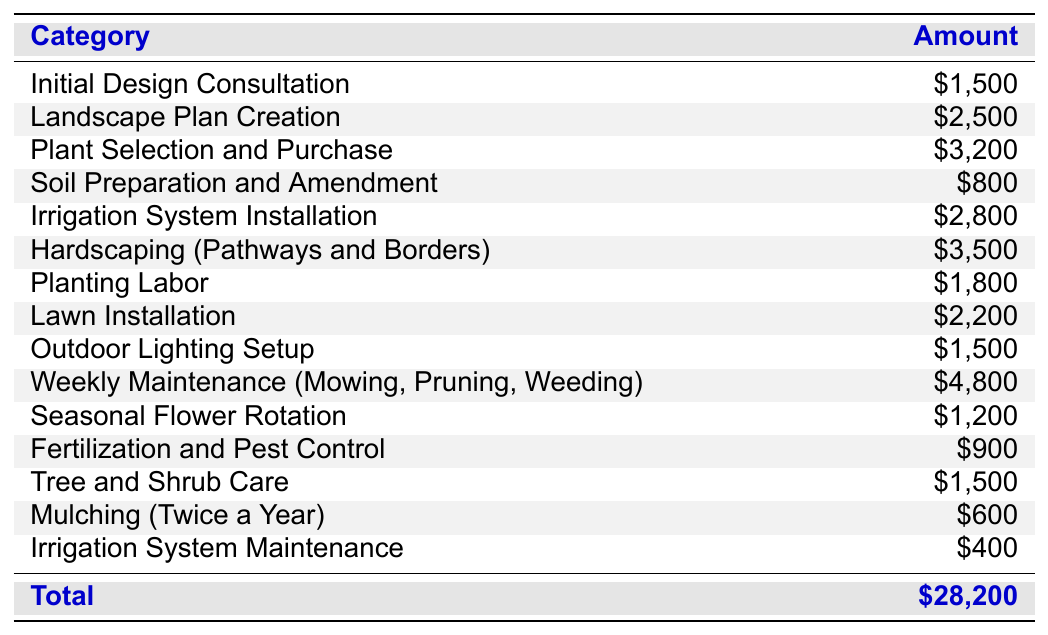What is the total amount allocated for the garden budget? The total amount is explicitly listed in the last row of the table as $28,200.
Answer: $28,200 How much is budgeted for Weekly Maintenance? The amount allocated for Weekly Maintenance is found under that category in the table, which is $4,800.
Answer: $4,800 Which category has the highest budget allocation? The highest budget allocation can be identified by comparing the amounts in each row. Hardscaping (Pathways and Borders) has the highest amount at $3,500.
Answer: Hardscaping (Pathways and Borders) What is the combined total budget for Soil Preparation and Amendment and Fertilization and Pest Control? To find the combined total, sum the amounts for Soil Preparation ($800) and Fertilization ($900): 800 + 900 = 1,700.
Answer: $1,700 Is the amount allocated for Irrigation System Maintenance greater than the total budget for Mulching and Fertilization? First, calculate the total for Mulching ($600) and Fertilization ($900), which is 600 + 900 = 1,500. Irrigation System Maintenance is $400, which is less than $1,500.
Answer: No What is the average budget for all categories listed in the table? There are 14 categories with a total budget of $28,200. To find the average, divide the total by the number of categories: 28,200 / 14 = 2,014.29.
Answer: $2,014.29 How much more is allocated for Plant Selection and Purchase compared to Soil Preparation and Amendment? Subtract the amount for Soil Preparation ($800) from that for Plant Selection ($3,200): 3,200 - 800 = 2,400.
Answer: $2,400 What proportion of the total budget is spent on Weekly Maintenance? First, identify the amount for Weekly Maintenance ($4,800) and divide it by the total budget ($28,200): 4,800 / 28,200 ≈ 0.1694. This represents approximately 16.94% of the total budget.
Answer: 16.94% Is the budget for Lawn Installation more than that for Tree and Shrub Care? Compare the amounts directly: Lawn Installation is $2,200, and Tree and Shrub Care is $1,500. Since $2,200 is greater than $1,500, the answer is yes.
Answer: Yes What is the total cost saved if the homeowner decides not to do Mulching at all in the year? Mulching costs $600. The total savings from omitting this category would be equal to this amount itself.
Answer: $600 